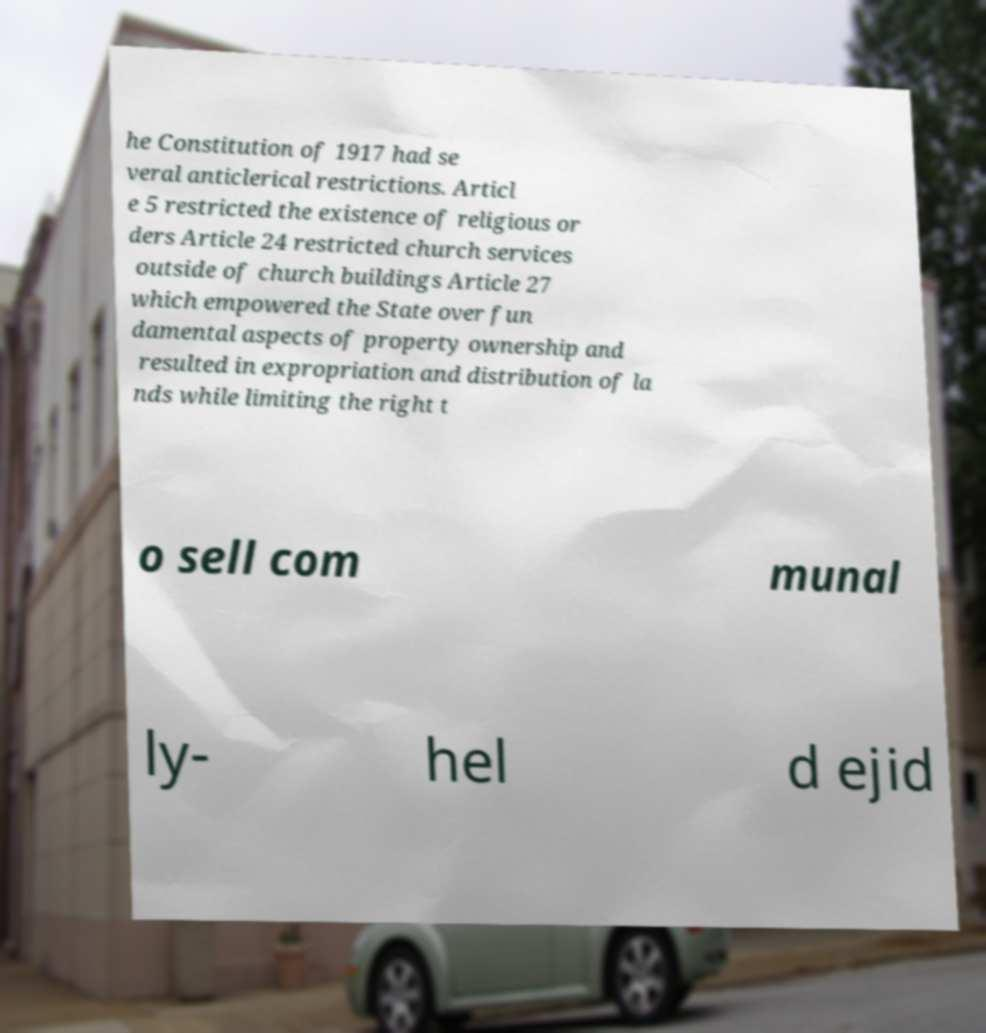I need the written content from this picture converted into text. Can you do that? he Constitution of 1917 had se veral anticlerical restrictions. Articl e 5 restricted the existence of religious or ders Article 24 restricted church services outside of church buildings Article 27 which empowered the State over fun damental aspects of property ownership and resulted in expropriation and distribution of la nds while limiting the right t o sell com munal ly- hel d ejid 